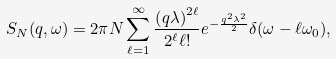<formula> <loc_0><loc_0><loc_500><loc_500>S _ { N } ( q , \omega ) = 2 \pi N \sum _ { \ell = 1 } ^ { \infty } \frac { \left ( q \lambda \right ) ^ { 2 \ell } } { 2 ^ { \ell } \ell ! } e ^ { - \frac { q ^ { 2 } \lambda ^ { 2 } } { 2 } } \delta ( \omega - \ell \omega _ { 0 } ) ,</formula> 